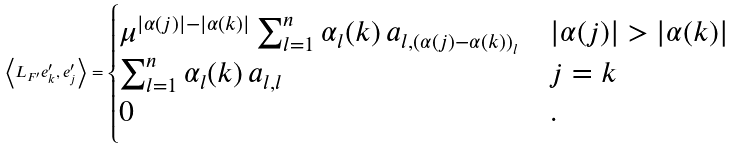<formula> <loc_0><loc_0><loc_500><loc_500>\left \langle L _ { F ^ { \prime } } e _ { k } ^ { \prime } , e _ { j } ^ { \prime } \right \rangle = \begin{cases} \mu ^ { | \alpha ( j ) | - | \alpha ( k ) | } \sum _ { l = 1 } ^ { n } \alpha _ { l } ( k ) \, a _ { l , ( \alpha ( j ) - \alpha ( k ) ) _ { l } } & | \alpha ( j ) | > | \alpha ( k ) | \\ \sum _ { l = 1 } ^ { n } \alpha _ { l } ( k ) \, a _ { l , l } & j = k \\ 0 & . \end{cases}</formula> 